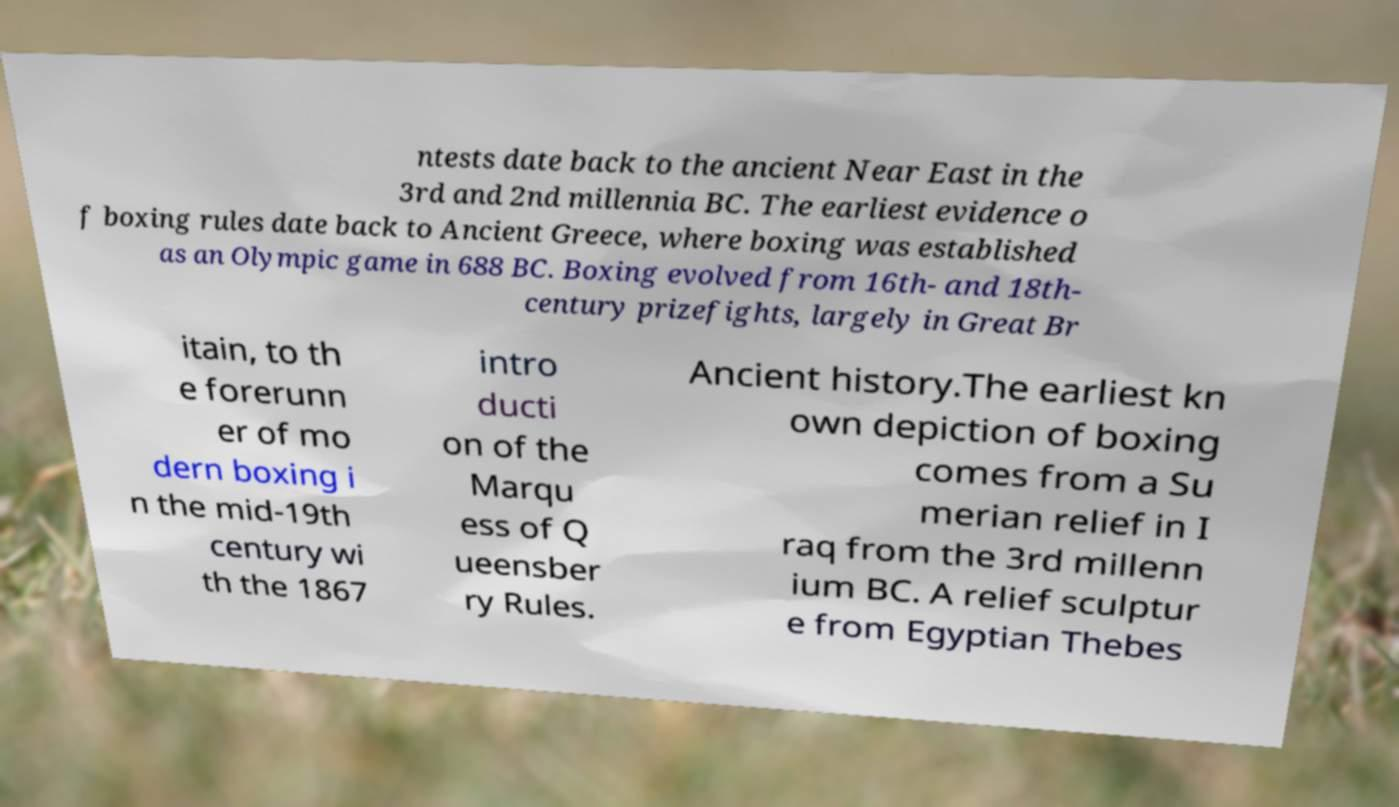Can you read and provide the text displayed in the image?This photo seems to have some interesting text. Can you extract and type it out for me? ntests date back to the ancient Near East in the 3rd and 2nd millennia BC. The earliest evidence o f boxing rules date back to Ancient Greece, where boxing was established as an Olympic game in 688 BC. Boxing evolved from 16th- and 18th- century prizefights, largely in Great Br itain, to th e forerunn er of mo dern boxing i n the mid-19th century wi th the 1867 intro ducti on of the Marqu ess of Q ueensber ry Rules. Ancient history.The earliest kn own depiction of boxing comes from a Su merian relief in I raq from the 3rd millenn ium BC. A relief sculptur e from Egyptian Thebes 